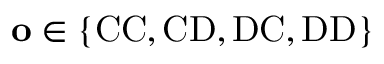<formula> <loc_0><loc_0><loc_500><loc_500>o \in \{ C C , C D , D C , D D \}</formula> 